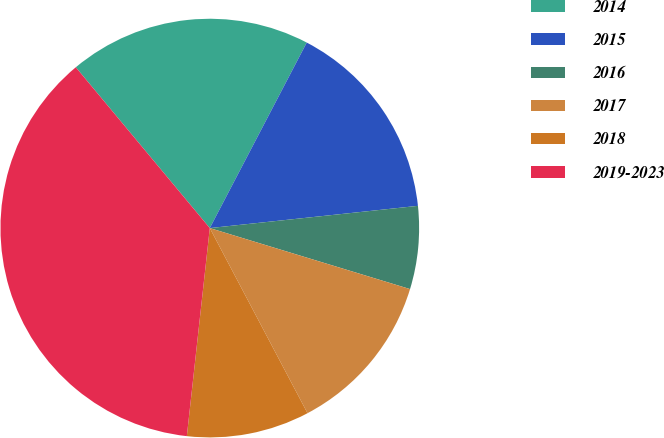Convert chart to OTSL. <chart><loc_0><loc_0><loc_500><loc_500><pie_chart><fcel>2014<fcel>2015<fcel>2016<fcel>2017<fcel>2018<fcel>2019-2023<nl><fcel>18.72%<fcel>15.64%<fcel>6.4%<fcel>12.56%<fcel>9.48%<fcel>37.19%<nl></chart> 